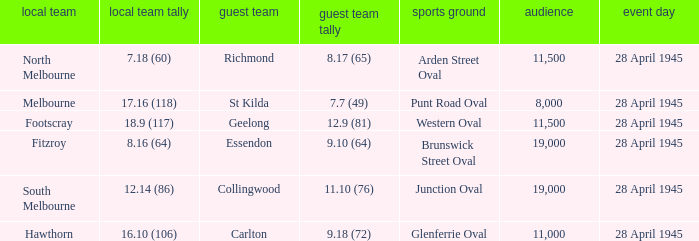What away team played at western oval? Geelong. 